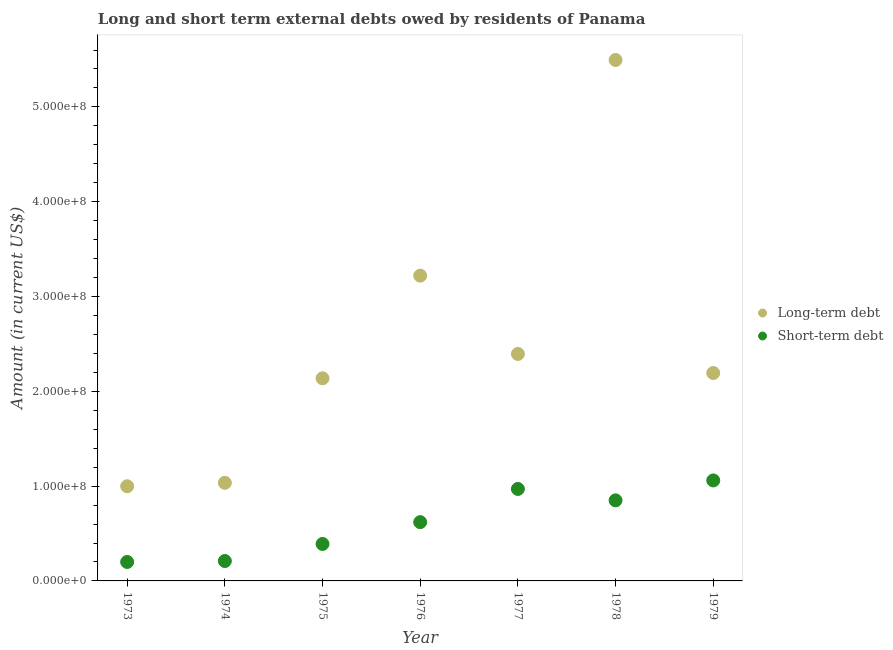What is the short-term debts owed by residents in 1975?
Provide a short and direct response. 3.90e+07. Across all years, what is the maximum short-term debts owed by residents?
Provide a short and direct response. 1.06e+08. Across all years, what is the minimum short-term debts owed by residents?
Keep it short and to the point. 2.00e+07. In which year was the long-term debts owed by residents maximum?
Ensure brevity in your answer.  1978. In which year was the short-term debts owed by residents minimum?
Keep it short and to the point. 1973. What is the total short-term debts owed by residents in the graph?
Offer a terse response. 4.30e+08. What is the difference between the long-term debts owed by residents in 1974 and that in 1978?
Give a very brief answer. -4.46e+08. What is the difference between the short-term debts owed by residents in 1974 and the long-term debts owed by residents in 1976?
Give a very brief answer. -3.01e+08. What is the average short-term debts owed by residents per year?
Ensure brevity in your answer.  6.14e+07. In the year 1973, what is the difference between the short-term debts owed by residents and long-term debts owed by residents?
Offer a terse response. -7.99e+07. What is the ratio of the short-term debts owed by residents in 1978 to that in 1979?
Ensure brevity in your answer.  0.8. Is the long-term debts owed by residents in 1974 less than that in 1978?
Give a very brief answer. Yes. What is the difference between the highest and the second highest long-term debts owed by residents?
Your answer should be compact. 2.28e+08. What is the difference between the highest and the lowest short-term debts owed by residents?
Offer a very short reply. 8.60e+07. Does the long-term debts owed by residents monotonically increase over the years?
Offer a very short reply. No. Is the long-term debts owed by residents strictly greater than the short-term debts owed by residents over the years?
Your answer should be compact. Yes. How many dotlines are there?
Make the answer very short. 2. How many years are there in the graph?
Offer a very short reply. 7. Does the graph contain any zero values?
Your response must be concise. No. Does the graph contain grids?
Provide a short and direct response. No. Where does the legend appear in the graph?
Keep it short and to the point. Center right. How many legend labels are there?
Provide a short and direct response. 2. What is the title of the graph?
Provide a short and direct response. Long and short term external debts owed by residents of Panama. What is the label or title of the X-axis?
Ensure brevity in your answer.  Year. What is the Amount (in current US$) in Long-term debt in 1973?
Your response must be concise. 9.99e+07. What is the Amount (in current US$) of Long-term debt in 1974?
Offer a very short reply. 1.03e+08. What is the Amount (in current US$) of Short-term debt in 1974?
Your answer should be very brief. 2.10e+07. What is the Amount (in current US$) of Long-term debt in 1975?
Provide a short and direct response. 2.14e+08. What is the Amount (in current US$) of Short-term debt in 1975?
Offer a very short reply. 3.90e+07. What is the Amount (in current US$) in Long-term debt in 1976?
Provide a short and direct response. 3.22e+08. What is the Amount (in current US$) in Short-term debt in 1976?
Make the answer very short. 6.20e+07. What is the Amount (in current US$) in Long-term debt in 1977?
Your response must be concise. 2.39e+08. What is the Amount (in current US$) in Short-term debt in 1977?
Ensure brevity in your answer.  9.70e+07. What is the Amount (in current US$) in Long-term debt in 1978?
Your answer should be compact. 5.50e+08. What is the Amount (in current US$) of Short-term debt in 1978?
Your response must be concise. 8.50e+07. What is the Amount (in current US$) in Long-term debt in 1979?
Offer a terse response. 2.19e+08. What is the Amount (in current US$) of Short-term debt in 1979?
Ensure brevity in your answer.  1.06e+08. Across all years, what is the maximum Amount (in current US$) of Long-term debt?
Offer a terse response. 5.50e+08. Across all years, what is the maximum Amount (in current US$) of Short-term debt?
Make the answer very short. 1.06e+08. Across all years, what is the minimum Amount (in current US$) in Long-term debt?
Provide a succinct answer. 9.99e+07. Across all years, what is the minimum Amount (in current US$) of Short-term debt?
Your response must be concise. 2.00e+07. What is the total Amount (in current US$) of Long-term debt in the graph?
Ensure brevity in your answer.  1.75e+09. What is the total Amount (in current US$) of Short-term debt in the graph?
Your answer should be compact. 4.30e+08. What is the difference between the Amount (in current US$) of Long-term debt in 1973 and that in 1974?
Make the answer very short. -3.63e+06. What is the difference between the Amount (in current US$) in Short-term debt in 1973 and that in 1974?
Your response must be concise. -1.00e+06. What is the difference between the Amount (in current US$) in Long-term debt in 1973 and that in 1975?
Offer a very short reply. -1.14e+08. What is the difference between the Amount (in current US$) in Short-term debt in 1973 and that in 1975?
Provide a succinct answer. -1.90e+07. What is the difference between the Amount (in current US$) in Long-term debt in 1973 and that in 1976?
Offer a terse response. -2.22e+08. What is the difference between the Amount (in current US$) of Short-term debt in 1973 and that in 1976?
Provide a short and direct response. -4.20e+07. What is the difference between the Amount (in current US$) in Long-term debt in 1973 and that in 1977?
Offer a terse response. -1.40e+08. What is the difference between the Amount (in current US$) in Short-term debt in 1973 and that in 1977?
Offer a terse response. -7.70e+07. What is the difference between the Amount (in current US$) of Long-term debt in 1973 and that in 1978?
Your answer should be very brief. -4.50e+08. What is the difference between the Amount (in current US$) in Short-term debt in 1973 and that in 1978?
Your answer should be very brief. -6.50e+07. What is the difference between the Amount (in current US$) in Long-term debt in 1973 and that in 1979?
Provide a short and direct response. -1.19e+08. What is the difference between the Amount (in current US$) of Short-term debt in 1973 and that in 1979?
Give a very brief answer. -8.60e+07. What is the difference between the Amount (in current US$) of Long-term debt in 1974 and that in 1975?
Offer a very short reply. -1.10e+08. What is the difference between the Amount (in current US$) of Short-term debt in 1974 and that in 1975?
Keep it short and to the point. -1.80e+07. What is the difference between the Amount (in current US$) in Long-term debt in 1974 and that in 1976?
Provide a short and direct response. -2.19e+08. What is the difference between the Amount (in current US$) in Short-term debt in 1974 and that in 1976?
Provide a short and direct response. -4.10e+07. What is the difference between the Amount (in current US$) in Long-term debt in 1974 and that in 1977?
Offer a terse response. -1.36e+08. What is the difference between the Amount (in current US$) in Short-term debt in 1974 and that in 1977?
Offer a very short reply. -7.60e+07. What is the difference between the Amount (in current US$) of Long-term debt in 1974 and that in 1978?
Keep it short and to the point. -4.46e+08. What is the difference between the Amount (in current US$) in Short-term debt in 1974 and that in 1978?
Ensure brevity in your answer.  -6.40e+07. What is the difference between the Amount (in current US$) in Long-term debt in 1974 and that in 1979?
Offer a very short reply. -1.16e+08. What is the difference between the Amount (in current US$) of Short-term debt in 1974 and that in 1979?
Give a very brief answer. -8.50e+07. What is the difference between the Amount (in current US$) of Long-term debt in 1975 and that in 1976?
Offer a very short reply. -1.08e+08. What is the difference between the Amount (in current US$) in Short-term debt in 1975 and that in 1976?
Your response must be concise. -2.30e+07. What is the difference between the Amount (in current US$) of Long-term debt in 1975 and that in 1977?
Provide a short and direct response. -2.57e+07. What is the difference between the Amount (in current US$) of Short-term debt in 1975 and that in 1977?
Your response must be concise. -5.80e+07. What is the difference between the Amount (in current US$) in Long-term debt in 1975 and that in 1978?
Give a very brief answer. -3.36e+08. What is the difference between the Amount (in current US$) in Short-term debt in 1975 and that in 1978?
Offer a very short reply. -4.60e+07. What is the difference between the Amount (in current US$) in Long-term debt in 1975 and that in 1979?
Provide a short and direct response. -5.56e+06. What is the difference between the Amount (in current US$) of Short-term debt in 1975 and that in 1979?
Offer a terse response. -6.70e+07. What is the difference between the Amount (in current US$) of Long-term debt in 1976 and that in 1977?
Ensure brevity in your answer.  8.26e+07. What is the difference between the Amount (in current US$) in Short-term debt in 1976 and that in 1977?
Make the answer very short. -3.50e+07. What is the difference between the Amount (in current US$) of Long-term debt in 1976 and that in 1978?
Make the answer very short. -2.28e+08. What is the difference between the Amount (in current US$) in Short-term debt in 1976 and that in 1978?
Your answer should be very brief. -2.30e+07. What is the difference between the Amount (in current US$) of Long-term debt in 1976 and that in 1979?
Provide a succinct answer. 1.03e+08. What is the difference between the Amount (in current US$) in Short-term debt in 1976 and that in 1979?
Your response must be concise. -4.40e+07. What is the difference between the Amount (in current US$) of Long-term debt in 1977 and that in 1978?
Your answer should be very brief. -3.10e+08. What is the difference between the Amount (in current US$) of Long-term debt in 1977 and that in 1979?
Your response must be concise. 2.01e+07. What is the difference between the Amount (in current US$) of Short-term debt in 1977 and that in 1979?
Keep it short and to the point. -9.00e+06. What is the difference between the Amount (in current US$) of Long-term debt in 1978 and that in 1979?
Your answer should be very brief. 3.30e+08. What is the difference between the Amount (in current US$) in Short-term debt in 1978 and that in 1979?
Keep it short and to the point. -2.10e+07. What is the difference between the Amount (in current US$) in Long-term debt in 1973 and the Amount (in current US$) in Short-term debt in 1974?
Offer a terse response. 7.89e+07. What is the difference between the Amount (in current US$) in Long-term debt in 1973 and the Amount (in current US$) in Short-term debt in 1975?
Keep it short and to the point. 6.09e+07. What is the difference between the Amount (in current US$) in Long-term debt in 1973 and the Amount (in current US$) in Short-term debt in 1976?
Ensure brevity in your answer.  3.79e+07. What is the difference between the Amount (in current US$) in Long-term debt in 1973 and the Amount (in current US$) in Short-term debt in 1977?
Provide a succinct answer. 2.87e+06. What is the difference between the Amount (in current US$) in Long-term debt in 1973 and the Amount (in current US$) in Short-term debt in 1978?
Provide a succinct answer. 1.49e+07. What is the difference between the Amount (in current US$) in Long-term debt in 1973 and the Amount (in current US$) in Short-term debt in 1979?
Keep it short and to the point. -6.13e+06. What is the difference between the Amount (in current US$) of Long-term debt in 1974 and the Amount (in current US$) of Short-term debt in 1975?
Keep it short and to the point. 6.45e+07. What is the difference between the Amount (in current US$) of Long-term debt in 1974 and the Amount (in current US$) of Short-term debt in 1976?
Offer a terse response. 4.15e+07. What is the difference between the Amount (in current US$) of Long-term debt in 1974 and the Amount (in current US$) of Short-term debt in 1977?
Provide a succinct answer. 6.50e+06. What is the difference between the Amount (in current US$) in Long-term debt in 1974 and the Amount (in current US$) in Short-term debt in 1978?
Offer a terse response. 1.85e+07. What is the difference between the Amount (in current US$) in Long-term debt in 1974 and the Amount (in current US$) in Short-term debt in 1979?
Provide a succinct answer. -2.50e+06. What is the difference between the Amount (in current US$) in Long-term debt in 1975 and the Amount (in current US$) in Short-term debt in 1976?
Offer a very short reply. 1.52e+08. What is the difference between the Amount (in current US$) in Long-term debt in 1975 and the Amount (in current US$) in Short-term debt in 1977?
Your response must be concise. 1.17e+08. What is the difference between the Amount (in current US$) in Long-term debt in 1975 and the Amount (in current US$) in Short-term debt in 1978?
Provide a short and direct response. 1.29e+08. What is the difference between the Amount (in current US$) of Long-term debt in 1975 and the Amount (in current US$) of Short-term debt in 1979?
Provide a succinct answer. 1.08e+08. What is the difference between the Amount (in current US$) in Long-term debt in 1976 and the Amount (in current US$) in Short-term debt in 1977?
Your answer should be very brief. 2.25e+08. What is the difference between the Amount (in current US$) of Long-term debt in 1976 and the Amount (in current US$) of Short-term debt in 1978?
Your response must be concise. 2.37e+08. What is the difference between the Amount (in current US$) of Long-term debt in 1976 and the Amount (in current US$) of Short-term debt in 1979?
Keep it short and to the point. 2.16e+08. What is the difference between the Amount (in current US$) in Long-term debt in 1977 and the Amount (in current US$) in Short-term debt in 1978?
Your answer should be very brief. 1.54e+08. What is the difference between the Amount (in current US$) in Long-term debt in 1977 and the Amount (in current US$) in Short-term debt in 1979?
Offer a very short reply. 1.33e+08. What is the difference between the Amount (in current US$) in Long-term debt in 1978 and the Amount (in current US$) in Short-term debt in 1979?
Offer a very short reply. 4.44e+08. What is the average Amount (in current US$) in Long-term debt per year?
Ensure brevity in your answer.  2.50e+08. What is the average Amount (in current US$) of Short-term debt per year?
Ensure brevity in your answer.  6.14e+07. In the year 1973, what is the difference between the Amount (in current US$) of Long-term debt and Amount (in current US$) of Short-term debt?
Offer a very short reply. 7.99e+07. In the year 1974, what is the difference between the Amount (in current US$) of Long-term debt and Amount (in current US$) of Short-term debt?
Ensure brevity in your answer.  8.25e+07. In the year 1975, what is the difference between the Amount (in current US$) in Long-term debt and Amount (in current US$) in Short-term debt?
Provide a short and direct response. 1.75e+08. In the year 1976, what is the difference between the Amount (in current US$) of Long-term debt and Amount (in current US$) of Short-term debt?
Your response must be concise. 2.60e+08. In the year 1977, what is the difference between the Amount (in current US$) of Long-term debt and Amount (in current US$) of Short-term debt?
Offer a very short reply. 1.42e+08. In the year 1978, what is the difference between the Amount (in current US$) of Long-term debt and Amount (in current US$) of Short-term debt?
Give a very brief answer. 4.65e+08. In the year 1979, what is the difference between the Amount (in current US$) in Long-term debt and Amount (in current US$) in Short-term debt?
Give a very brief answer. 1.13e+08. What is the ratio of the Amount (in current US$) in Long-term debt in 1973 to that in 1974?
Ensure brevity in your answer.  0.96. What is the ratio of the Amount (in current US$) of Long-term debt in 1973 to that in 1975?
Your answer should be compact. 0.47. What is the ratio of the Amount (in current US$) of Short-term debt in 1973 to that in 1975?
Provide a short and direct response. 0.51. What is the ratio of the Amount (in current US$) of Long-term debt in 1973 to that in 1976?
Offer a terse response. 0.31. What is the ratio of the Amount (in current US$) of Short-term debt in 1973 to that in 1976?
Offer a very short reply. 0.32. What is the ratio of the Amount (in current US$) in Long-term debt in 1973 to that in 1977?
Offer a very short reply. 0.42. What is the ratio of the Amount (in current US$) of Short-term debt in 1973 to that in 1977?
Give a very brief answer. 0.21. What is the ratio of the Amount (in current US$) in Long-term debt in 1973 to that in 1978?
Provide a succinct answer. 0.18. What is the ratio of the Amount (in current US$) in Short-term debt in 1973 to that in 1978?
Provide a short and direct response. 0.24. What is the ratio of the Amount (in current US$) in Long-term debt in 1973 to that in 1979?
Offer a terse response. 0.46. What is the ratio of the Amount (in current US$) in Short-term debt in 1973 to that in 1979?
Keep it short and to the point. 0.19. What is the ratio of the Amount (in current US$) of Long-term debt in 1974 to that in 1975?
Ensure brevity in your answer.  0.48. What is the ratio of the Amount (in current US$) of Short-term debt in 1974 to that in 1975?
Your response must be concise. 0.54. What is the ratio of the Amount (in current US$) in Long-term debt in 1974 to that in 1976?
Keep it short and to the point. 0.32. What is the ratio of the Amount (in current US$) of Short-term debt in 1974 to that in 1976?
Offer a very short reply. 0.34. What is the ratio of the Amount (in current US$) of Long-term debt in 1974 to that in 1977?
Keep it short and to the point. 0.43. What is the ratio of the Amount (in current US$) of Short-term debt in 1974 to that in 1977?
Provide a short and direct response. 0.22. What is the ratio of the Amount (in current US$) of Long-term debt in 1974 to that in 1978?
Offer a very short reply. 0.19. What is the ratio of the Amount (in current US$) in Short-term debt in 1974 to that in 1978?
Give a very brief answer. 0.25. What is the ratio of the Amount (in current US$) in Long-term debt in 1974 to that in 1979?
Provide a short and direct response. 0.47. What is the ratio of the Amount (in current US$) in Short-term debt in 1974 to that in 1979?
Offer a very short reply. 0.2. What is the ratio of the Amount (in current US$) in Long-term debt in 1975 to that in 1976?
Offer a terse response. 0.66. What is the ratio of the Amount (in current US$) of Short-term debt in 1975 to that in 1976?
Give a very brief answer. 0.63. What is the ratio of the Amount (in current US$) in Long-term debt in 1975 to that in 1977?
Provide a short and direct response. 0.89. What is the ratio of the Amount (in current US$) in Short-term debt in 1975 to that in 1977?
Your response must be concise. 0.4. What is the ratio of the Amount (in current US$) in Long-term debt in 1975 to that in 1978?
Your answer should be very brief. 0.39. What is the ratio of the Amount (in current US$) of Short-term debt in 1975 to that in 1978?
Ensure brevity in your answer.  0.46. What is the ratio of the Amount (in current US$) in Long-term debt in 1975 to that in 1979?
Provide a short and direct response. 0.97. What is the ratio of the Amount (in current US$) of Short-term debt in 1975 to that in 1979?
Ensure brevity in your answer.  0.37. What is the ratio of the Amount (in current US$) in Long-term debt in 1976 to that in 1977?
Provide a short and direct response. 1.34. What is the ratio of the Amount (in current US$) of Short-term debt in 1976 to that in 1977?
Ensure brevity in your answer.  0.64. What is the ratio of the Amount (in current US$) of Long-term debt in 1976 to that in 1978?
Provide a short and direct response. 0.59. What is the ratio of the Amount (in current US$) of Short-term debt in 1976 to that in 1978?
Your answer should be compact. 0.73. What is the ratio of the Amount (in current US$) in Long-term debt in 1976 to that in 1979?
Offer a very short reply. 1.47. What is the ratio of the Amount (in current US$) of Short-term debt in 1976 to that in 1979?
Give a very brief answer. 0.58. What is the ratio of the Amount (in current US$) in Long-term debt in 1977 to that in 1978?
Provide a succinct answer. 0.44. What is the ratio of the Amount (in current US$) of Short-term debt in 1977 to that in 1978?
Provide a succinct answer. 1.14. What is the ratio of the Amount (in current US$) in Long-term debt in 1977 to that in 1979?
Your response must be concise. 1.09. What is the ratio of the Amount (in current US$) in Short-term debt in 1977 to that in 1979?
Keep it short and to the point. 0.92. What is the ratio of the Amount (in current US$) of Long-term debt in 1978 to that in 1979?
Your answer should be compact. 2.51. What is the ratio of the Amount (in current US$) of Short-term debt in 1978 to that in 1979?
Offer a very short reply. 0.8. What is the difference between the highest and the second highest Amount (in current US$) of Long-term debt?
Give a very brief answer. 2.28e+08. What is the difference between the highest and the second highest Amount (in current US$) of Short-term debt?
Keep it short and to the point. 9.00e+06. What is the difference between the highest and the lowest Amount (in current US$) in Long-term debt?
Ensure brevity in your answer.  4.50e+08. What is the difference between the highest and the lowest Amount (in current US$) of Short-term debt?
Ensure brevity in your answer.  8.60e+07. 